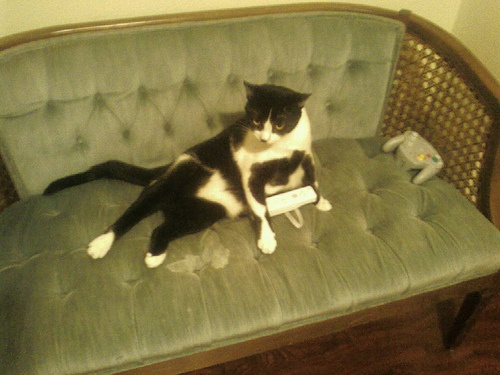Describe the objects in this image and their specific colors. I can see couch in olive, khaki, and black tones, cat in khaki, black, and olive tones, remote in khaki, tan, and olive tones, and remote in khaki, lightyellow, tan, and olive tones in this image. 